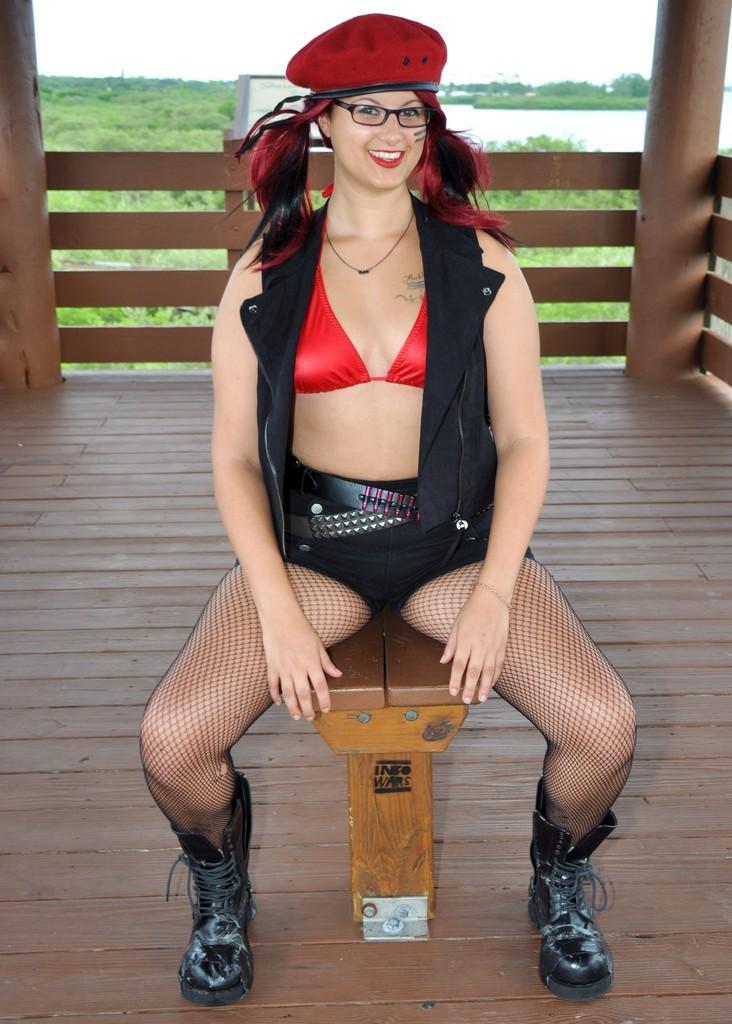Please provide a concise description of this image. In the image,there is a woman sitting on a wooden tool and around the woman there is a fencing of wood,in the background there is a beautiful scenery. 